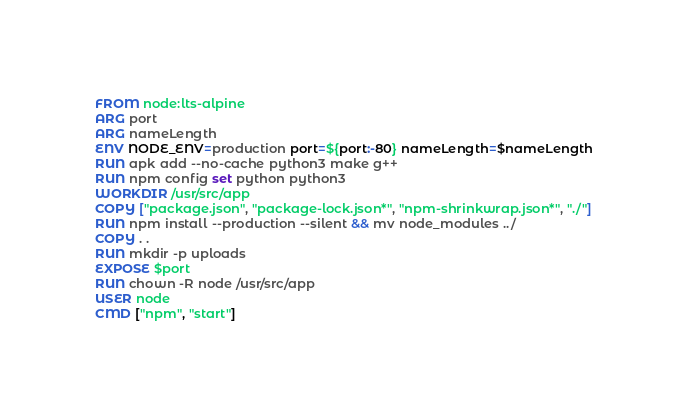Convert code to text. <code><loc_0><loc_0><loc_500><loc_500><_Dockerfile_>FROM node:lts-alpine
ARG port
ARG nameLength
ENV NODE_ENV=production port=${port:-80} nameLength=$nameLength
RUN apk add --no-cache python3 make g++
RUN npm config set python python3
WORKDIR /usr/src/app
COPY ["package.json", "package-lock.json*", "npm-shrinkwrap.json*", "./"]
RUN npm install --production --silent && mv node_modules ../
COPY . .
RUN mkdir -p uploads
EXPOSE $port
RUN chown -R node /usr/src/app
USER node
CMD ["npm", "start"]
</code> 